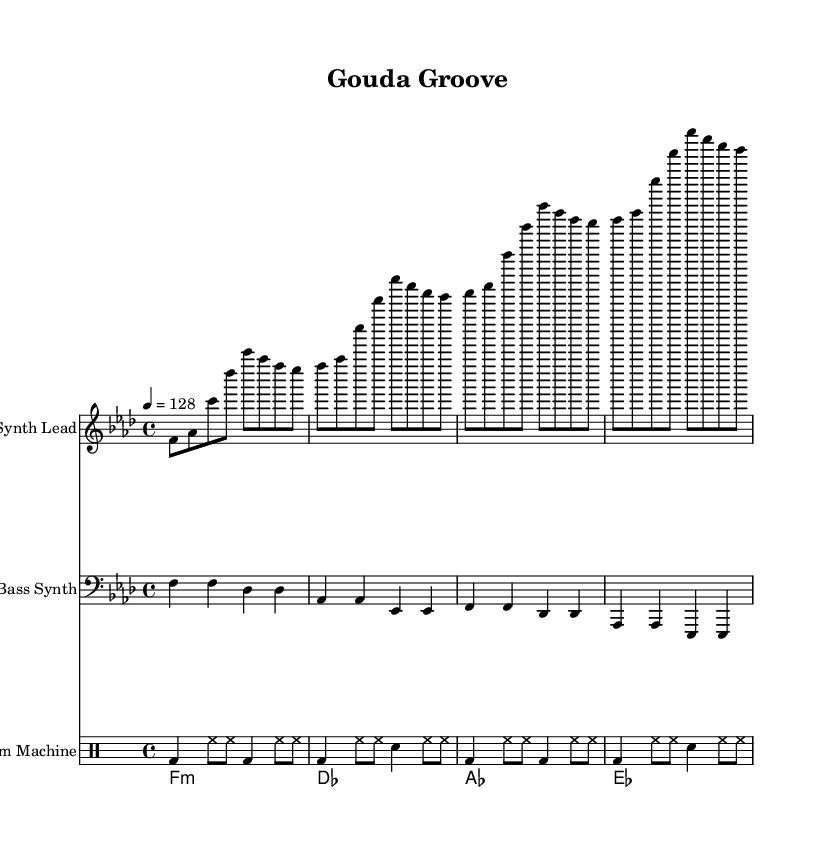What is the key signature of this music? The key signature indicates F minor. This can be identified by looking at the symbols at the beginning of the staff, which show four flats.
Answer: F minor What is the time signature of this music? The time signature is represented as 4/4, which is shown at the beginning of the score. This means there are four beats per measure, and the quarter note gets one beat.
Answer: 4/4 What is the tempo marking of this music? The tempo marking is indicated at the beginning as "4 = 128," meaning the quarter note is played at 128 beats per minute.
Answer: 128 What is the first note of the synth lead? The first note of the synth lead is F, as it is the first note written in the sequence for the synth lead staff.
Answer: F How many measures are there in the synth lead? There are four measures in the synth lead section, as indicated by the four groups of notes that fit within the 4/4 time signature.
Answer: 4 What type of rhythmic pattern does the drum machine use? The drum machine uses a repetitive pattern, incorporating bass and hi-hat notes, suitable for electronic dance music, as seen by the alternating bass drum and hi-hat notations in the drummode.
Answer: Repetitive Which chord is played on the first beat of the second measure? The chord played on the first beat of the second measure is D flat major. This can be checked in the chord Brahms mode, where the first chord of the second measure is explicitly noted.
Answer: D flat major 